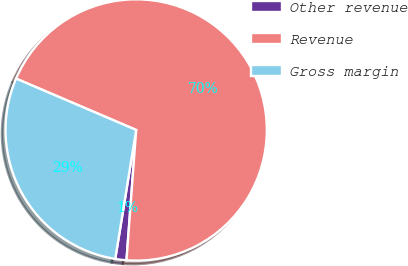Convert chart. <chart><loc_0><loc_0><loc_500><loc_500><pie_chart><fcel>Other revenue<fcel>Revenue<fcel>Gross margin<nl><fcel>1.38%<fcel>69.75%<fcel>28.87%<nl></chart> 